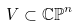Convert formula to latex. <formula><loc_0><loc_0><loc_500><loc_500>V \subset \mathbb { C P } ^ { n }</formula> 